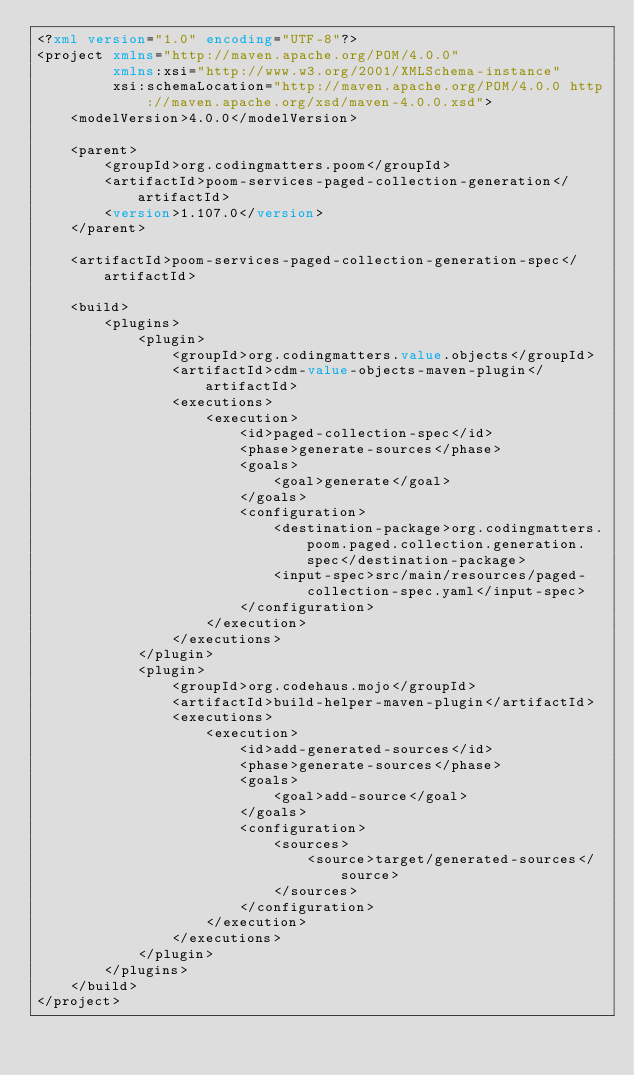Convert code to text. <code><loc_0><loc_0><loc_500><loc_500><_XML_><?xml version="1.0" encoding="UTF-8"?>
<project xmlns="http://maven.apache.org/POM/4.0.0"
         xmlns:xsi="http://www.w3.org/2001/XMLSchema-instance"
         xsi:schemaLocation="http://maven.apache.org/POM/4.0.0 http://maven.apache.org/xsd/maven-4.0.0.xsd">
    <modelVersion>4.0.0</modelVersion>

    <parent>
        <groupId>org.codingmatters.poom</groupId>
        <artifactId>poom-services-paged-collection-generation</artifactId>
        <version>1.107.0</version>
    </parent>

    <artifactId>poom-services-paged-collection-generation-spec</artifactId>

    <build>
        <plugins>
            <plugin>
                <groupId>org.codingmatters.value.objects</groupId>
                <artifactId>cdm-value-objects-maven-plugin</artifactId>
                <executions>
                    <execution>
                        <id>paged-collection-spec</id>
                        <phase>generate-sources</phase>
                        <goals>
                            <goal>generate</goal>
                        </goals>
                        <configuration>
                            <destination-package>org.codingmatters.poom.paged.collection.generation.spec</destination-package>
                            <input-spec>src/main/resources/paged-collection-spec.yaml</input-spec>
                        </configuration>
                    </execution>
                </executions>
            </plugin>
            <plugin>
                <groupId>org.codehaus.mojo</groupId>
                <artifactId>build-helper-maven-plugin</artifactId>
                <executions>
                    <execution>
                        <id>add-generated-sources</id>
                        <phase>generate-sources</phase>
                        <goals>
                            <goal>add-source</goal>
                        </goals>
                        <configuration>
                            <sources>
                                <source>target/generated-sources</source>
                            </sources>
                        </configuration>
                    </execution>
                </executions>
            </plugin>
        </plugins>
    </build>
</project></code> 